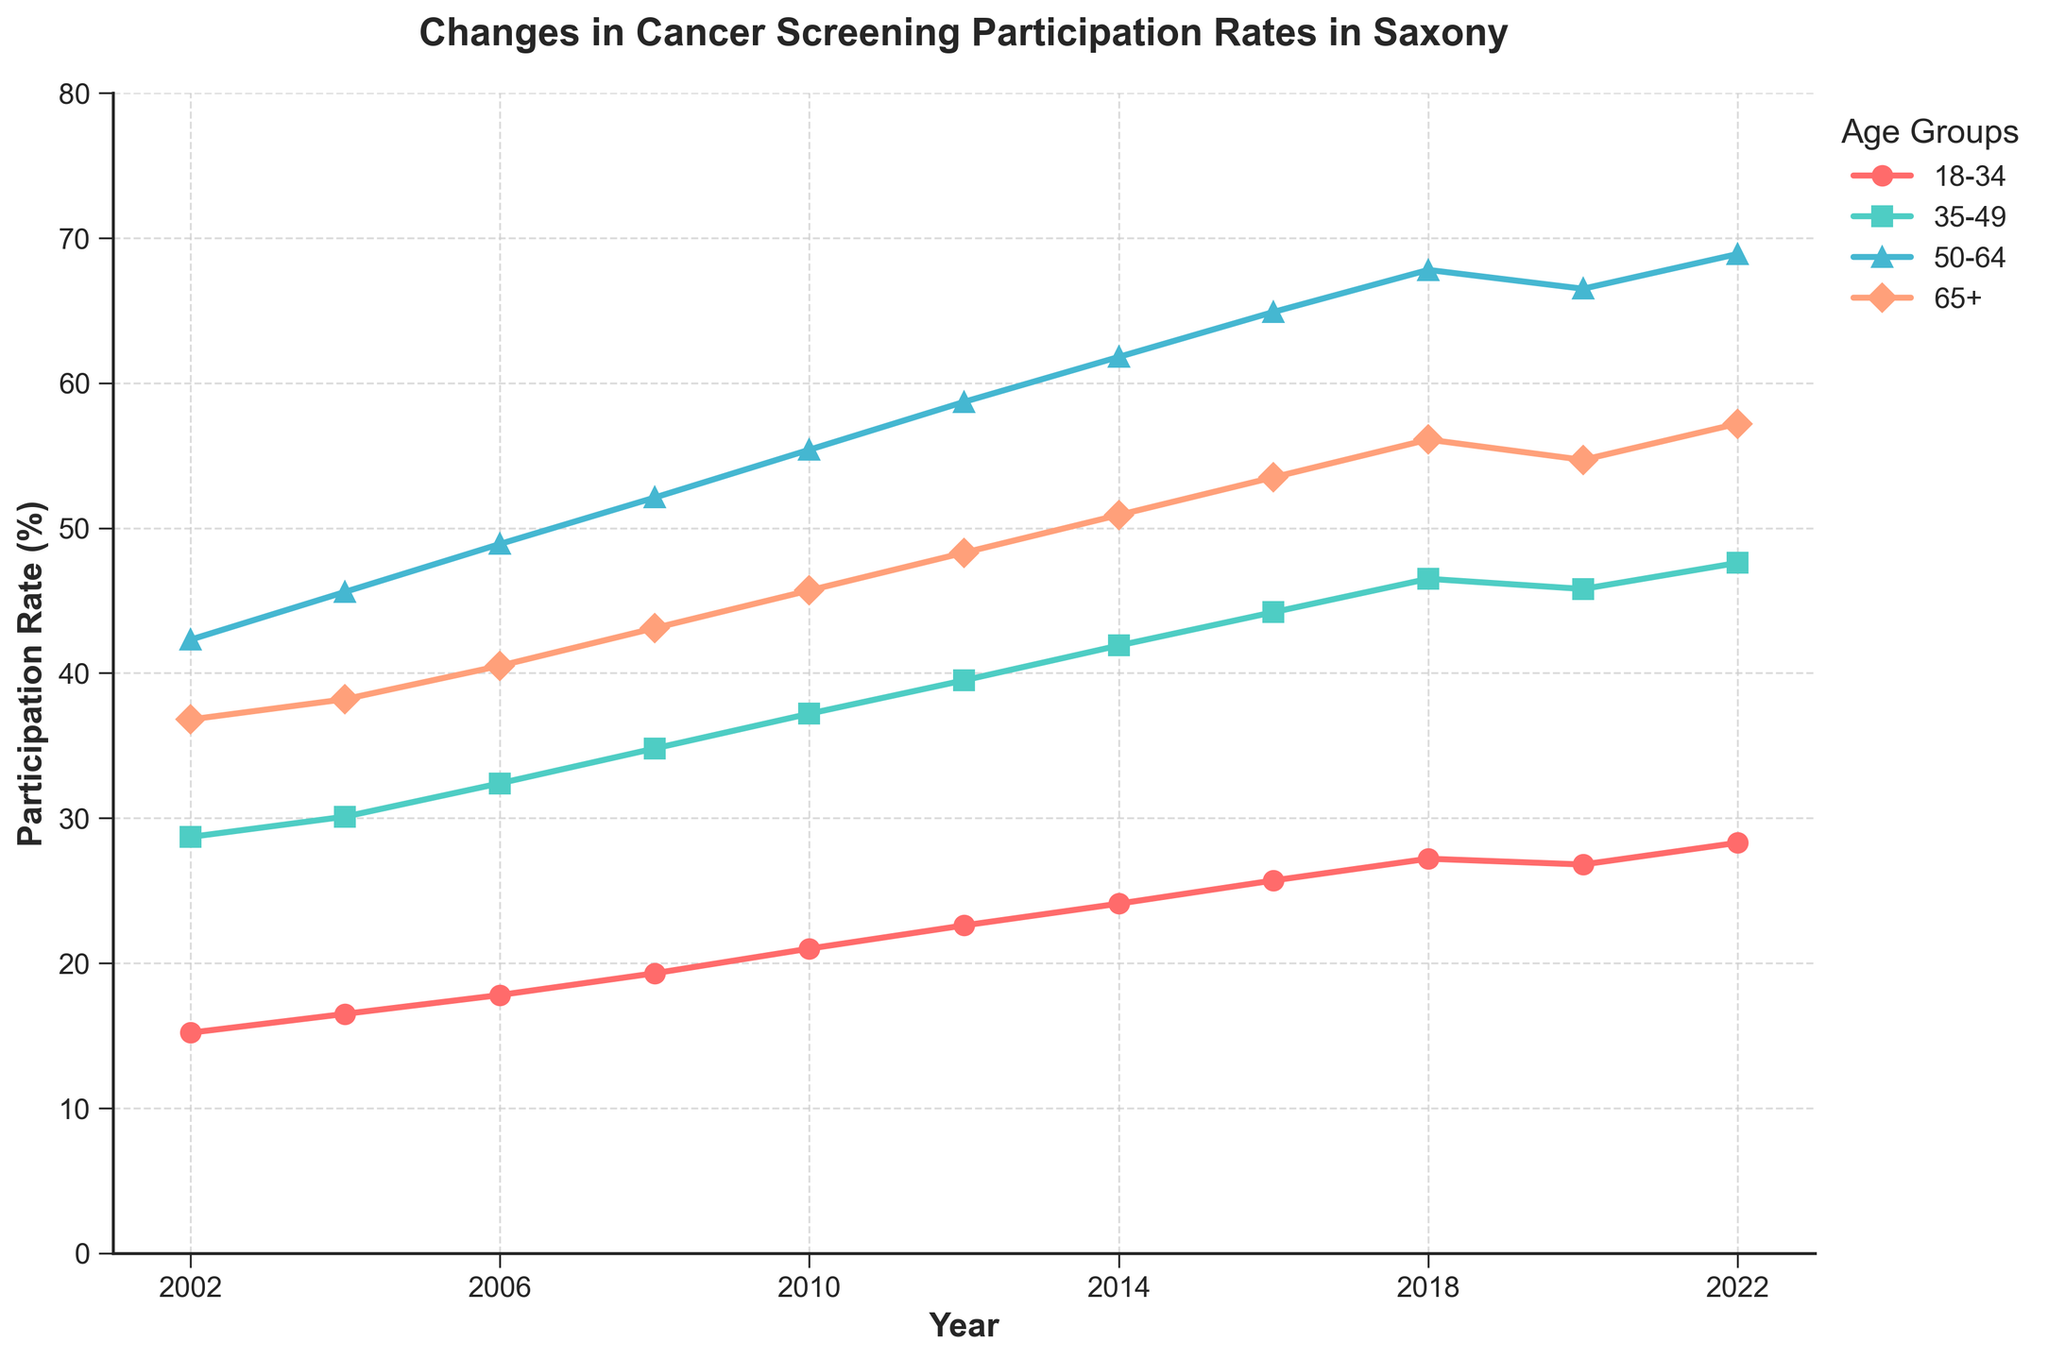What is the overall trend in cancer screening participation rates for the age group 65+ between 2002 and 2022? Look at the line corresponding to the age group 65+. It starts at 36.8 in 2002 and rises to 57.2 in 2022.
Answer: The trend is increasing Which age group had the highest participation rate in 2010? Locate the year 2010 and compare the participation rates for all age groups. 50-64 has the highest rate at 55.4.
Answer: Age group 50-64 In what year did the 35-49 age group's screening participation rate first exceed 40%? Follow the line for the 35-49 age group and find the first point where it crosses 40%, which is in 2012.
Answer: 2012 Which age group had the smallest change in screening participation rate between 2002 and 2022? Calculate the difference between 2022 and 2002 for each age group: 
1. 18-34: 28.3 - 15.2 = 13.1
2. 35-49: 47.6 - 28.7 = 18.9
3. 50-64: 68.9 - 42.3 = 26.6
4. 65+: 57.2 - 36.8 = 20.4
The smallest change is 13.1 for age group 18-34.
Answer: Age group 18-34 What was the participation rate for the age group 50-64 in 2016? Find the year 2016 and look up the participation rate for age group 50-64, which is 64.9.
Answer: 64.9% How does the participation rate for the age group 18-34 compare from 2002 to 2020? Compare the values of 18-34 in 2002 and 2020. The rate went from 15.2 in 2002 to 26.8 in 2020.
Answer: The rate increased What is the average participation rate for the age group 35-49 over the entire period? Add the participation rates for 35-49 from 2002 to 2022 and divide by the number of years: 
(28.7 + 30.1 + 32.4 + 34.8 + 37.2 + 39.5 + 41.9 + 44.2 + 46.5 + 45.8 + 47.6) / 11 = 38.1
Answer: 38.1 Which age group showed the most consistent increase in participation rates from 2002 to 2018? Analyze the lines visually to see steady increases. Age group 65+ shows a consistent and clear increase each year from 2002 to 2018.
Answer: Age group 65+ Did any age group experience a decrease in participation rates between 2018 and 2020? Compare the participation rates for all age groups in 2018 and 2020. Only 18-34 shows a decrease from 27.2 to 26.8.
Answer: Age group 18-34 